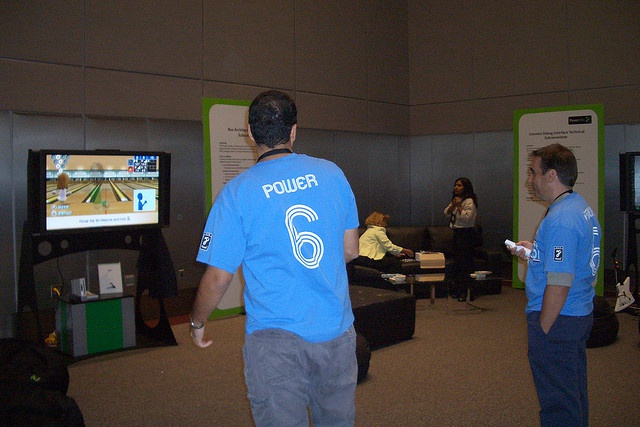Describe the objects in this image and their specific colors. I can see people in black, lightblue, and gray tones, people in black, blue, gray, and navy tones, tv in black, tan, lightgray, and gray tones, couch in black, maroon, and gray tones, and couch in black and gray tones in this image. 